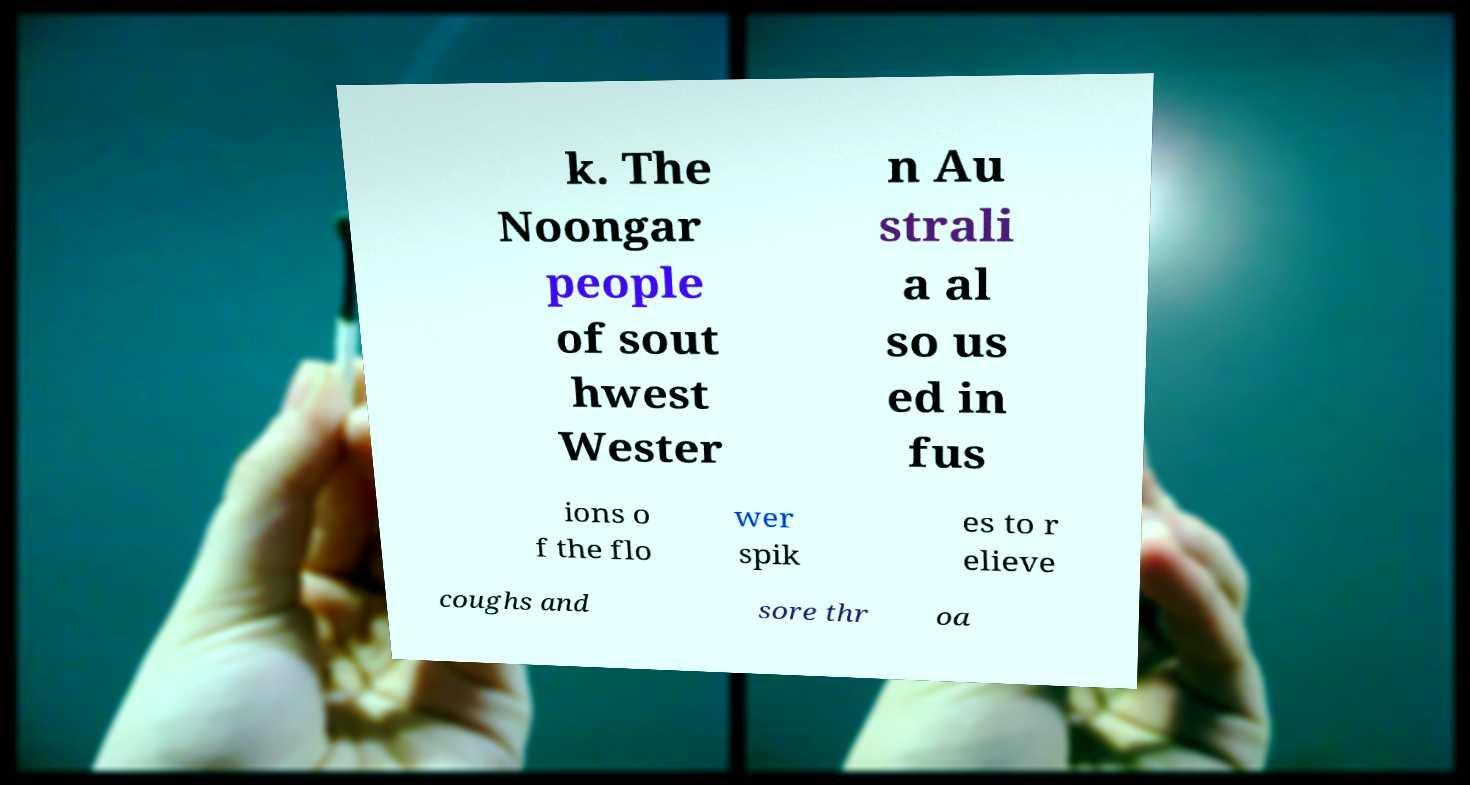I need the written content from this picture converted into text. Can you do that? k. The Noongar people of sout hwest Wester n Au strali a al so us ed in fus ions o f the flo wer spik es to r elieve coughs and sore thr oa 